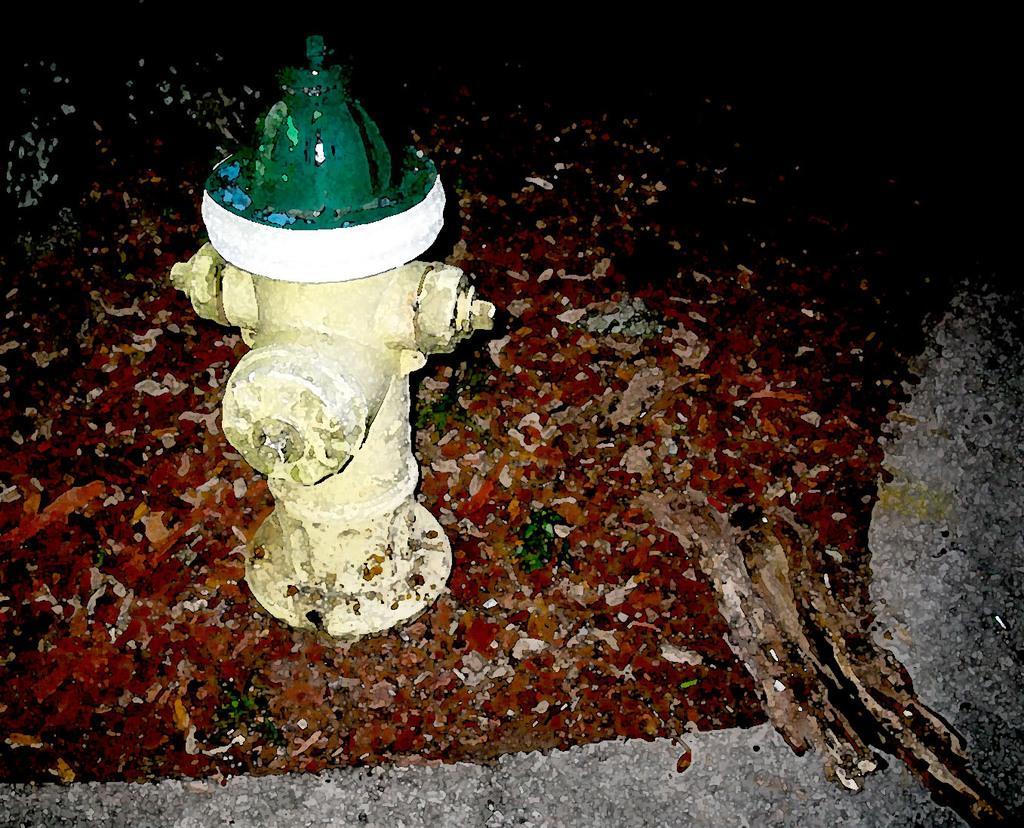Could you give a brief overview of what you see in this image? In this image we can see a fire hydrant on the colorful surface. 